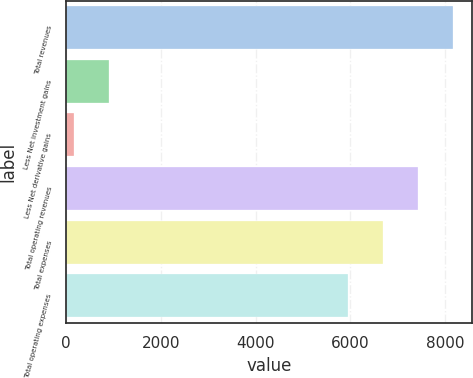Convert chart. <chart><loc_0><loc_0><loc_500><loc_500><bar_chart><fcel>Total revenues<fcel>Less Net investment gains<fcel>Less Net derivative gains<fcel>Total operating revenues<fcel>Total expenses<fcel>Total operating expenses<nl><fcel>8170.8<fcel>902.6<fcel>162<fcel>7430.2<fcel>6689.6<fcel>5949<nl></chart> 